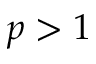Convert formula to latex. <formula><loc_0><loc_0><loc_500><loc_500>p > 1</formula> 